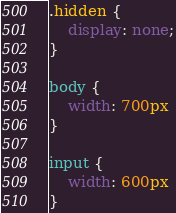Convert code to text. <code><loc_0><loc_0><loc_500><loc_500><_CSS_>.hidden {
    display: none;
}

body {
    width: 700px
}

input {
    width: 600px
}</code> 